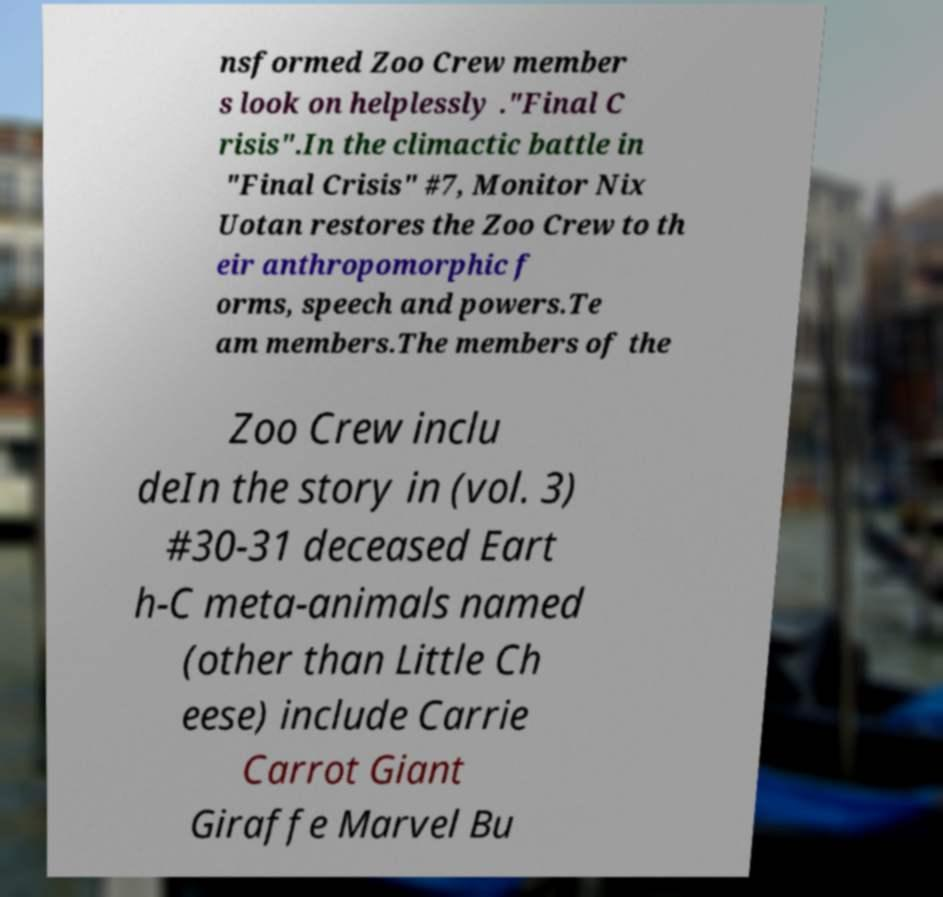For documentation purposes, I need the text within this image transcribed. Could you provide that? nsformed Zoo Crew member s look on helplessly ."Final C risis".In the climactic battle in "Final Crisis" #7, Monitor Nix Uotan restores the Zoo Crew to th eir anthropomorphic f orms, speech and powers.Te am members.The members of the Zoo Crew inclu deIn the story in (vol. 3) #30-31 deceased Eart h-C meta-animals named (other than Little Ch eese) include Carrie Carrot Giant Giraffe Marvel Bu 